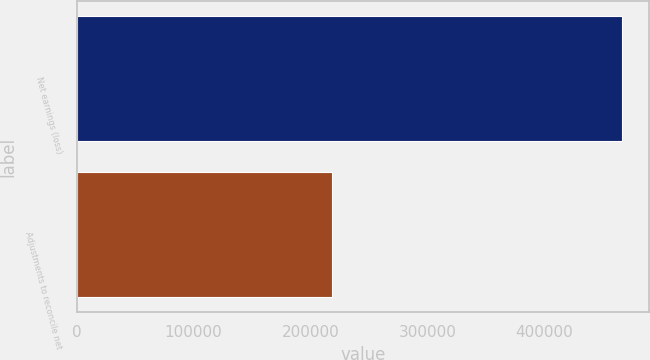Convert chart to OTSL. <chart><loc_0><loc_0><loc_500><loc_500><bar_chart><fcel>Net earnings (loss)<fcel>Adjustments to reconcile net<nl><fcel>465847<fcel>217936<nl></chart> 